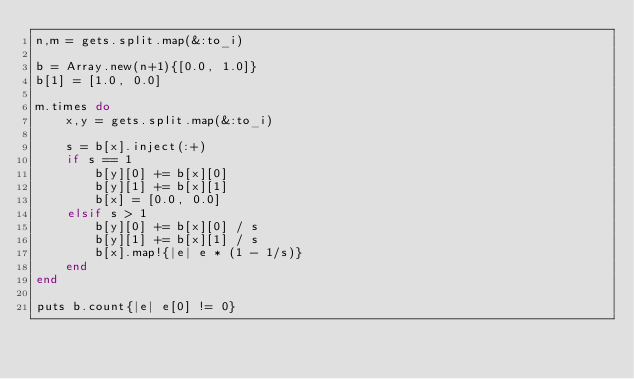<code> <loc_0><loc_0><loc_500><loc_500><_Ruby_>n,m = gets.split.map(&:to_i)

b = Array.new(n+1){[0.0, 1.0]}
b[1] = [1.0, 0.0]

m.times do
    x,y = gets.split.map(&:to_i)
   
    s = b[x].inject(:+)
    if s == 1
        b[y][0] += b[x][0]
        b[y][1] += b[x][1]
        b[x] = [0.0, 0.0]
    elsif s > 1
        b[y][0] += b[x][0] / s
        b[y][1] += b[x][1] / s
        b[x].map!{|e| e * (1 - 1/s)}
    end
end

puts b.count{|e| e[0] != 0}</code> 